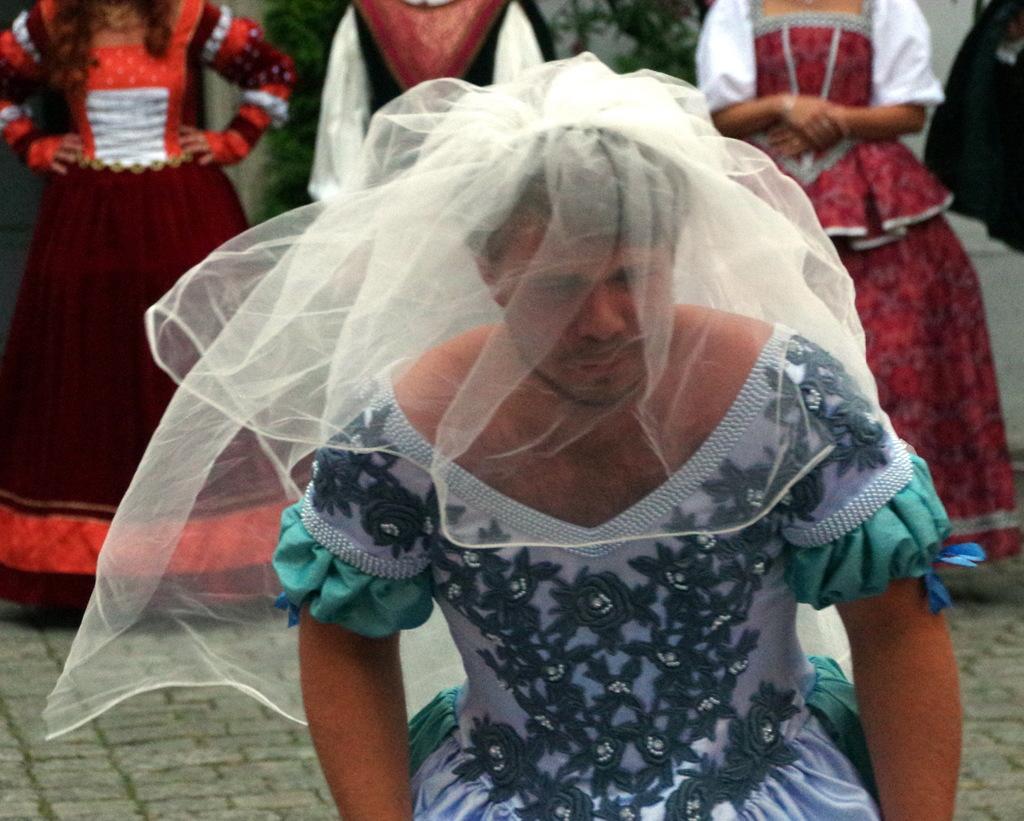Please provide a concise description of this image. In this picture we can see a person on the ground and in the background we can see persons. 